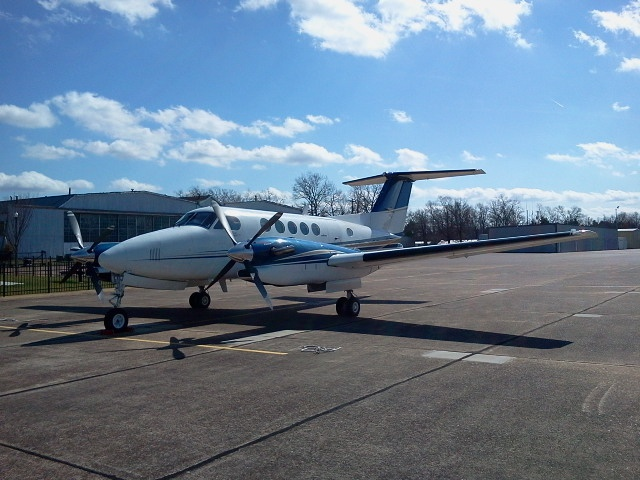Describe the objects in this image and their specific colors. I can see a airplane in gray, black, blue, and navy tones in this image. 